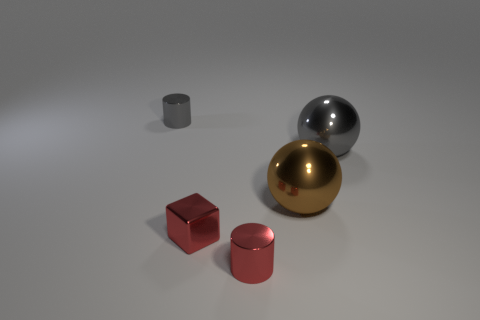There is a cylinder that is the same color as the tiny metallic block; what size is it?
Provide a succinct answer. Small. There is a thing that is the same color as the metallic cube; what is its shape?
Provide a short and direct response. Cylinder. How many objects are either things on the right side of the tiny red metallic cylinder or small shiny things?
Your response must be concise. 5. What number of cylinders are there?
Offer a terse response. 2. The small gray object that is the same material as the tiny red cylinder is what shape?
Your answer should be compact. Cylinder. What is the size of the ball that is in front of the big thing that is behind the large brown ball?
Give a very brief answer. Large. What number of objects are either small cylinders that are right of the tiny gray shiny cylinder or gray metal things that are behind the big gray object?
Your answer should be compact. 2. Are there fewer small shiny blocks than brown metal cylinders?
Provide a short and direct response. No. What number of objects are either large purple metallic things or tiny cubes?
Offer a very short reply. 1. Does the large gray metal object have the same shape as the tiny gray object?
Keep it short and to the point. No. 